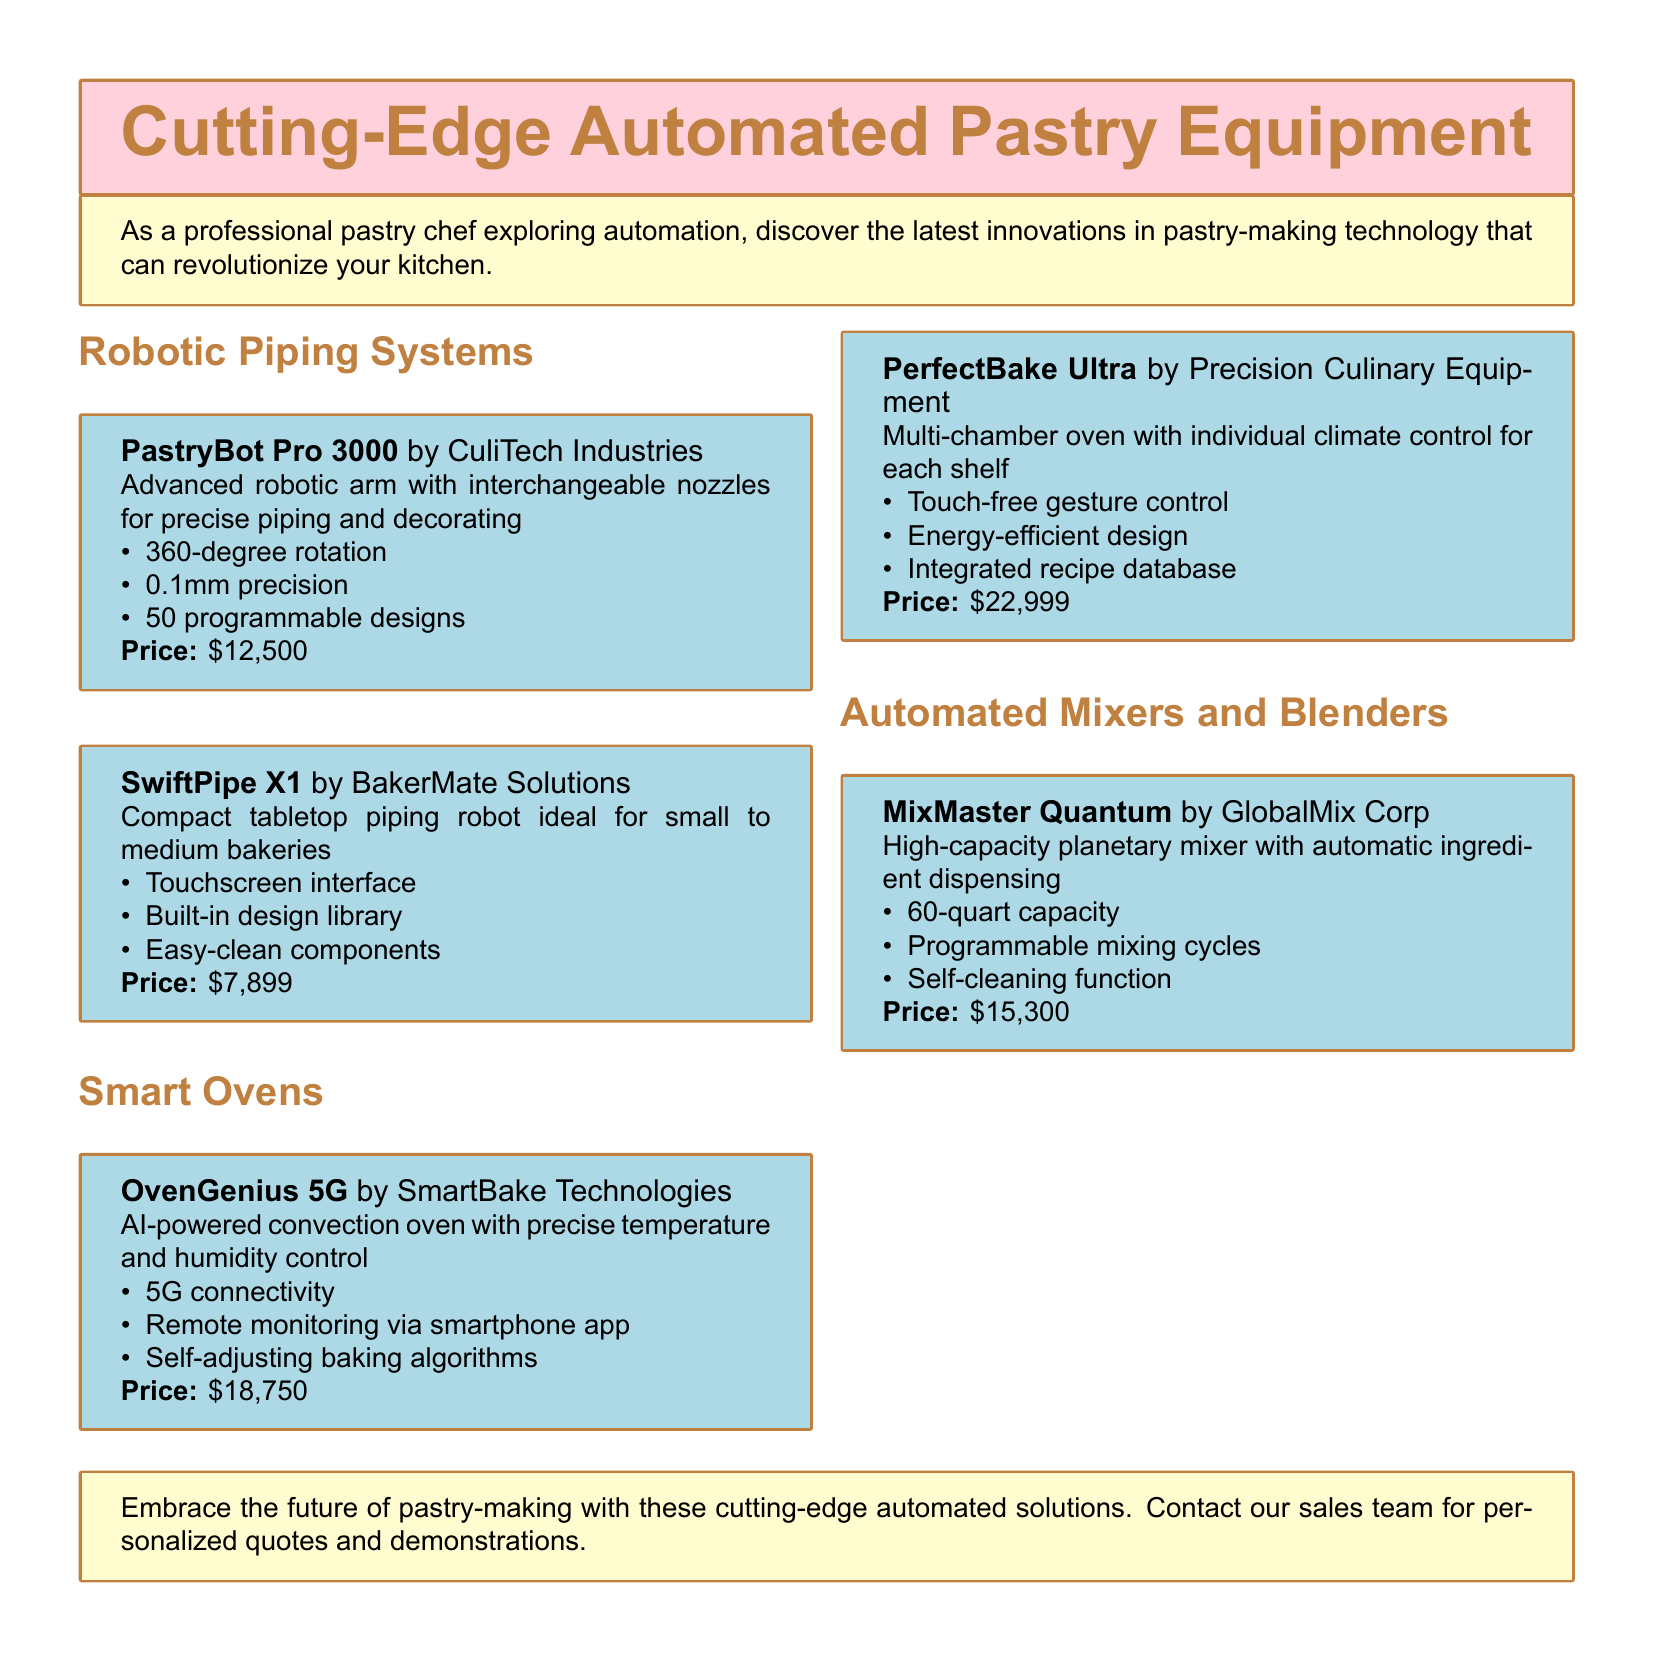What is the price of the PastryBot Pro 3000? The price of the PastryBot Pro 3000 is specifically mentioned in the document as $12,500.
Answer: $12,500 How many programmable designs does the SwiftPipe X1 have? The document states that the SwiftPipe X1 has a built-in design library, and while it doesn't specify the number, it can be inferred that it includes multiple designs intended for versatility in piping.
Answer: Not specified What is the capacity of the MixMaster Quantum? The MixMaster Quantum has a 60-quart capacity as detailed in the catalog.
Answer: 60-quart Which company manufactures the OvenGenius 5G? The document identifies SmartBake Technologies as the manufacturer of the OvenGenius 5G.
Answer: SmartBake Technologies What unique feature does the PerfectBake Ultra have? The PerfectBake Ultra includes a feature of individual climate control for each shelf, as highlighted in the specifications.
Answer: Individual climate control Which robotic system is ideal for small to medium bakeries? The catalog suggests that the SwiftPipe X1 is designed as a compact tabletop piping robot suitable for small to medium bakeries.
Answer: SwiftPipe X1 How does the OvenGenius 5G connect for remote monitoring? The OvenGenius 5G uses 5G connectivity for remote monitoring via a smartphone app, as described in the document.
Answer: 5G connectivity What cleaning feature is included in the MixMaster Quantum? The MixMaster Quantum features a self-cleaning function, which enhances its usability for pastry chefs.
Answer: Self-cleaning function 